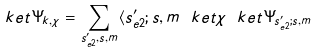Convert formula to latex. <formula><loc_0><loc_0><loc_500><loc_500>\ k e t { \Psi _ { k , \chi } } = \sum _ { s _ { e 2 } ^ { \prime } , s , m } \langle s _ { e 2 } ^ { \prime } ; s , m \ k e t { \chi } \ k e t { \Psi _ { s _ { e 2 } ^ { \prime } ; s , m } }</formula> 